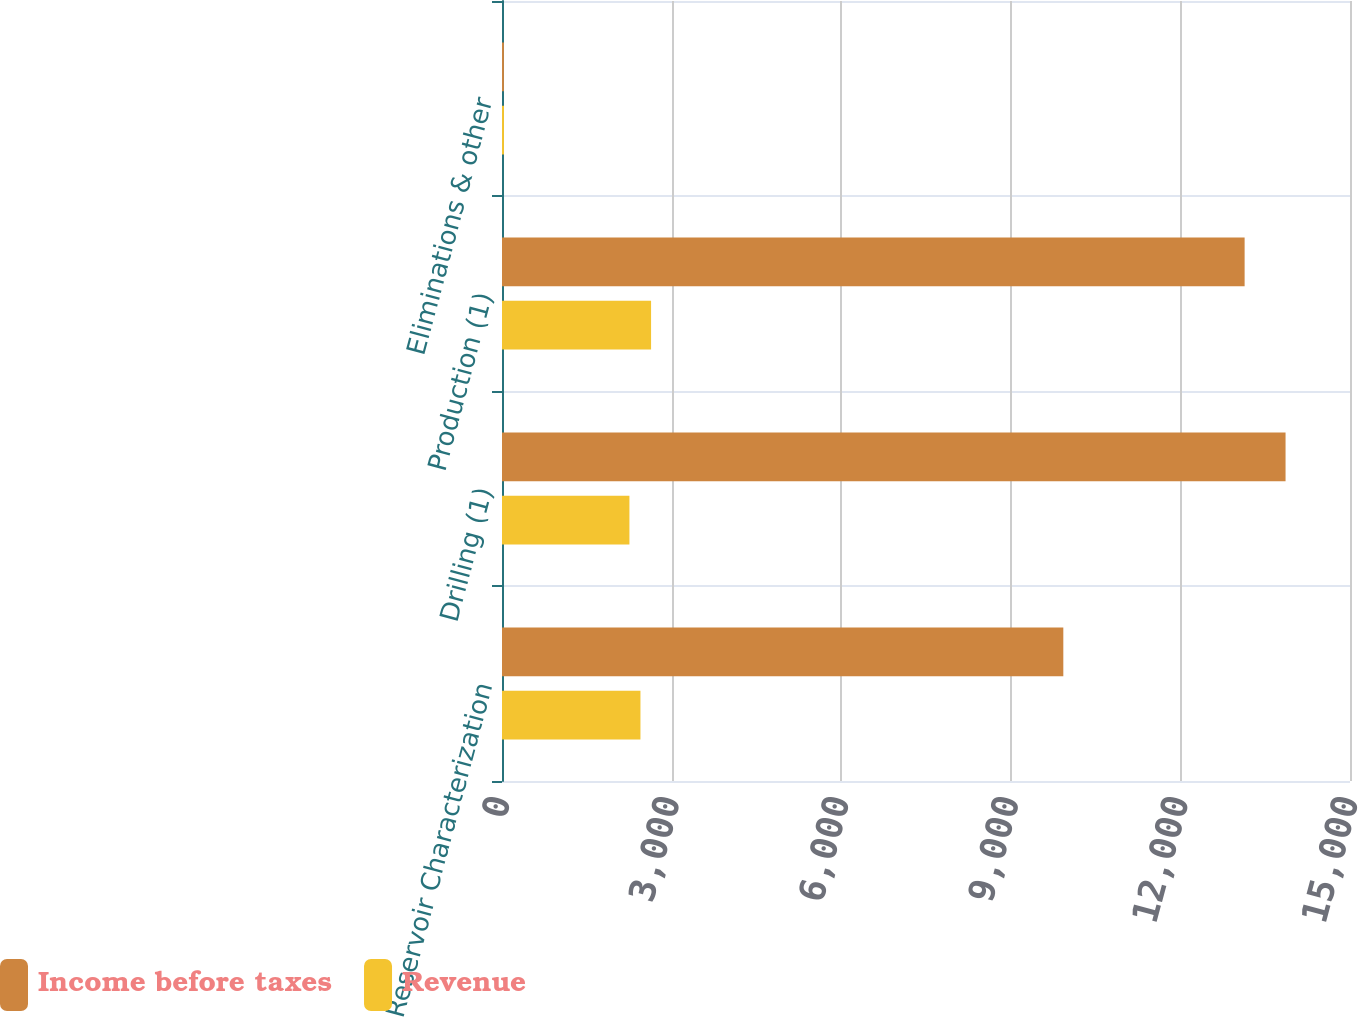Convert chart. <chart><loc_0><loc_0><loc_500><loc_500><stacked_bar_chart><ecel><fcel>Reservoir Characterization<fcel>Drilling (1)<fcel>Production (1)<fcel>Eliminations & other<nl><fcel>Income before taxes<fcel>9929<fcel>13860<fcel>13136<fcel>34<nl><fcel>Revenue<fcel>2449<fcel>2254<fcel>2637<fcel>35<nl></chart> 